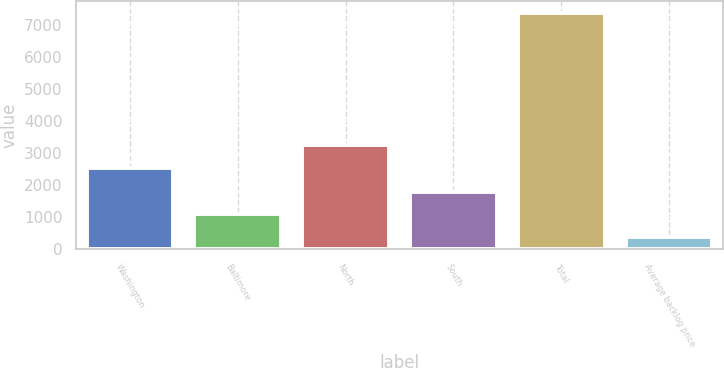Convert chart to OTSL. <chart><loc_0><loc_0><loc_500><loc_500><bar_chart><fcel>Washington<fcel>Baltimore<fcel>North<fcel>South<fcel>Total<fcel>Average backlog price<nl><fcel>2553<fcel>1091.98<fcel>3250.78<fcel>1789.76<fcel>7372<fcel>394.2<nl></chart> 